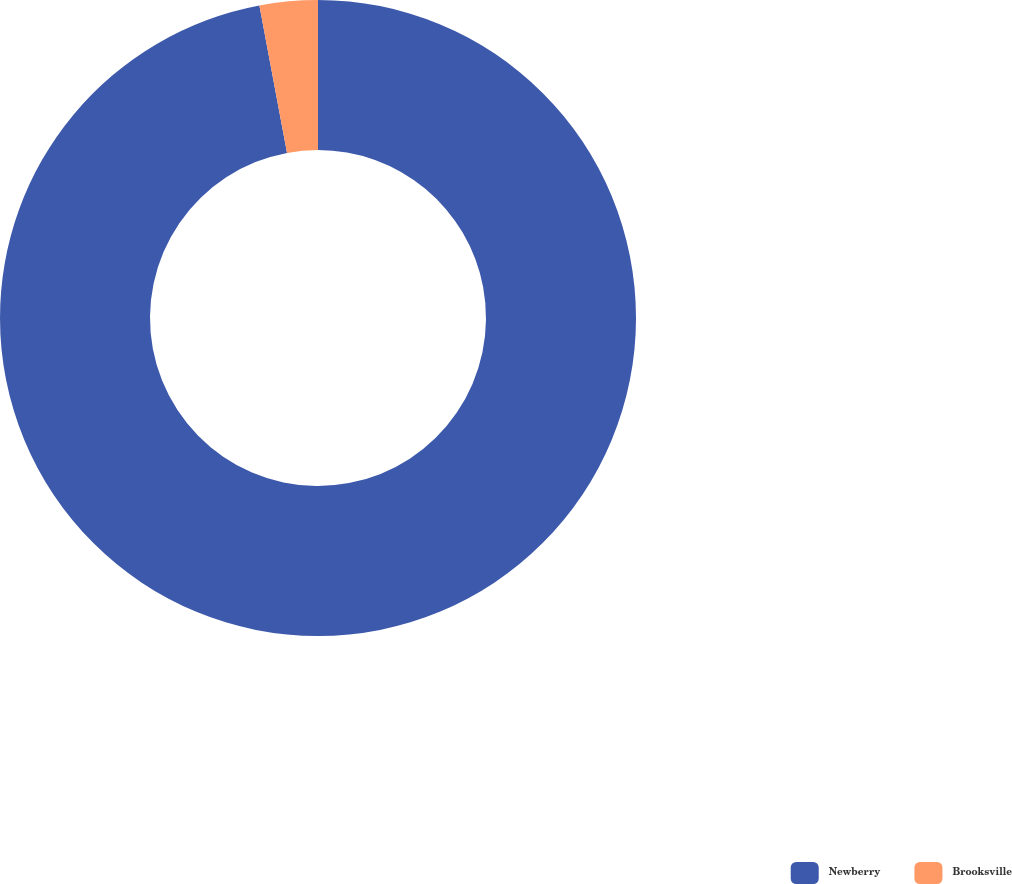Convert chart to OTSL. <chart><loc_0><loc_0><loc_500><loc_500><pie_chart><fcel>Newberry<fcel>Brooksville<nl><fcel>97.05%<fcel>2.95%<nl></chart> 